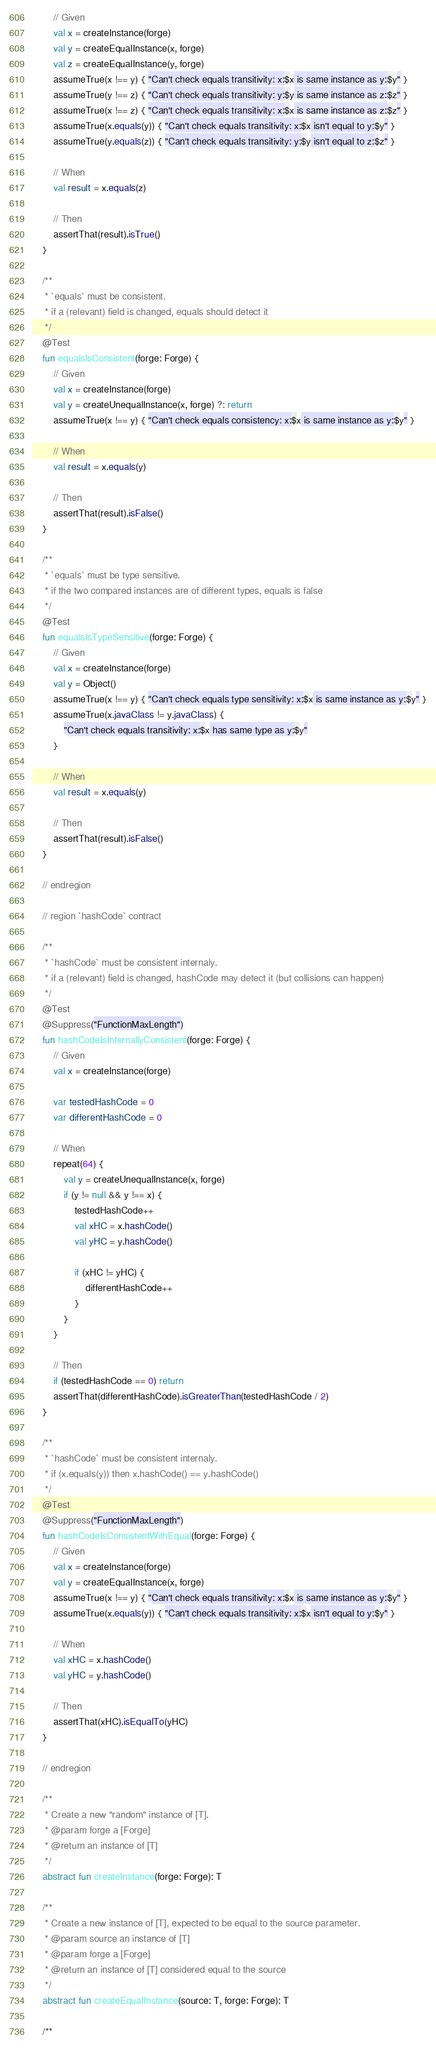Convert code to text. <code><loc_0><loc_0><loc_500><loc_500><_Kotlin_>        // Given
        val x = createInstance(forge)
        val y = createEqualInstance(x, forge)
        val z = createEqualInstance(y, forge)
        assumeTrue(x !== y) { "Can't check equals transitivity: x:$x is same instance as y:$y" }
        assumeTrue(y !== z) { "Can't check equals transitivity: y:$y is same instance as z:$z" }
        assumeTrue(x !== z) { "Can't check equals transitivity: x:$x is same instance as z:$z" }
        assumeTrue(x.equals(y)) { "Can't check equals transitivity: x:$x isn't equal to y:$y" }
        assumeTrue(y.equals(z)) { "Can't check equals transitivity: y:$y isn't equal to z:$z" }

        // When
        val result = x.equals(z)

        // Then
        assertThat(result).isTrue()
    }

    /**
     * `equals` must be consistent.
     * if a (relevant) field is changed, equals should detect it
     */
    @Test
    fun equalsIsConsistent(forge: Forge) {
        // Given
        val x = createInstance(forge)
        val y = createUnequalInstance(x, forge) ?: return
        assumeTrue(x !== y) { "Can't check equals consistency: x:$x is same instance as y:$y" }

        // When
        val result = x.equals(y)

        // Then
        assertThat(result).isFalse()
    }

    /**
     * `equals` must be type sensitive.
     * if the two compared instances are of different types, equals is false
     */
    @Test
    fun equalsIsTypeSensitive(forge: Forge) {
        // Given
        val x = createInstance(forge)
        val y = Object()
        assumeTrue(x !== y) { "Can't check equals type sensitivity: x:$x is same instance as y:$y" }
        assumeTrue(x.javaClass != y.javaClass) {
            "Can't check equals transitivity: x:$x has same type as y:$y"
        }

        // When
        val result = x.equals(y)

        // Then
        assertThat(result).isFalse()
    }

    // endregion

    // region `hashCode` contract

    /**
     * `hashCode` must be consistent internaly.
     * if a (relevant) field is changed, hashCode may detect it (but collisions can happen)
     */
    @Test
    @Suppress("FunctionMaxLength")
    fun hashCodeIsInternallyConsistent(forge: Forge) {
        // Given
        val x = createInstance(forge)

        var testedHashCode = 0
        var differentHashCode = 0

        // When
        repeat(64) {
            val y = createUnequalInstance(x, forge)
            if (y != null && y !== x) {
                testedHashCode++
                val xHC = x.hashCode()
                val yHC = y.hashCode()

                if (xHC != yHC) {
                    differentHashCode++
                }
            }
        }

        // Then
        if (testedHashCode == 0) return
        assertThat(differentHashCode).isGreaterThan(testedHashCode / 2)
    }

    /**
     * `hashCode` must be consistent internaly.
     * if (x.equals(y)) then x.hashCode() == y.hashCode()
     */
    @Test
    @Suppress("FunctionMaxLength")
    fun hashCodeIsConsistentWithEqual(forge: Forge) {
        // Given
        val x = createInstance(forge)
        val y = createEqualInstance(x, forge)
        assumeTrue(x !== y) { "Can't check equals transitivity: x:$x is same instance as y:$y" }
        assumeTrue(x.equals(y)) { "Can't check equals transitivity: x:$x isn't equal to y:$y" }

        // When
        val xHC = x.hashCode()
        val yHC = y.hashCode()

        // Then
        assertThat(xHC).isEqualTo(yHC)
    }

    // endregion

    /**
     * Create a new "random" instance of [T].
     * @param forge a [Forge]
     * @return an instance of [T]
     */
    abstract fun createInstance(forge: Forge): T

    /**
     * Create a new instance of [T], expected to be equal to the source parameter.
     * @param source an instance of [T]
     * @param forge a [Forge]
     * @return an instance of [T] considered equal to the source
     */
    abstract fun createEqualInstance(source: T, forge: Forge): T

    /**</code> 